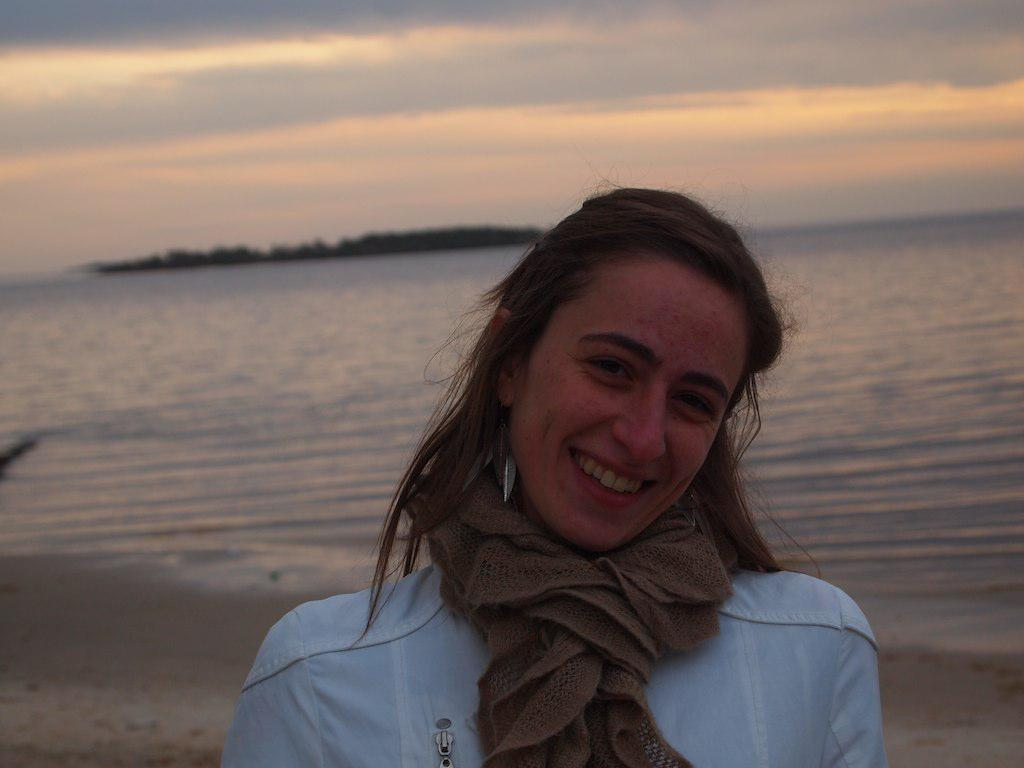What is the main subject in the image? There is a lady standing in the image. What can be seen under the lady's feet? The ground is visible in the image. What is the lady standing near? There is water visible in the image. What can be seen in the distance behind the lady? There are hills in the background of the image. What is visible above the lady and the hills? The sky is visible in the image. What is present in the sky? Clouds are present in the sky. What type of stamp can be seen on the lady's forehead in the image? There is no stamp present on the lady's forehead in the image. What type of wood is used to build the hills in the background? The hills in the background are natural formations and not made of wood. 